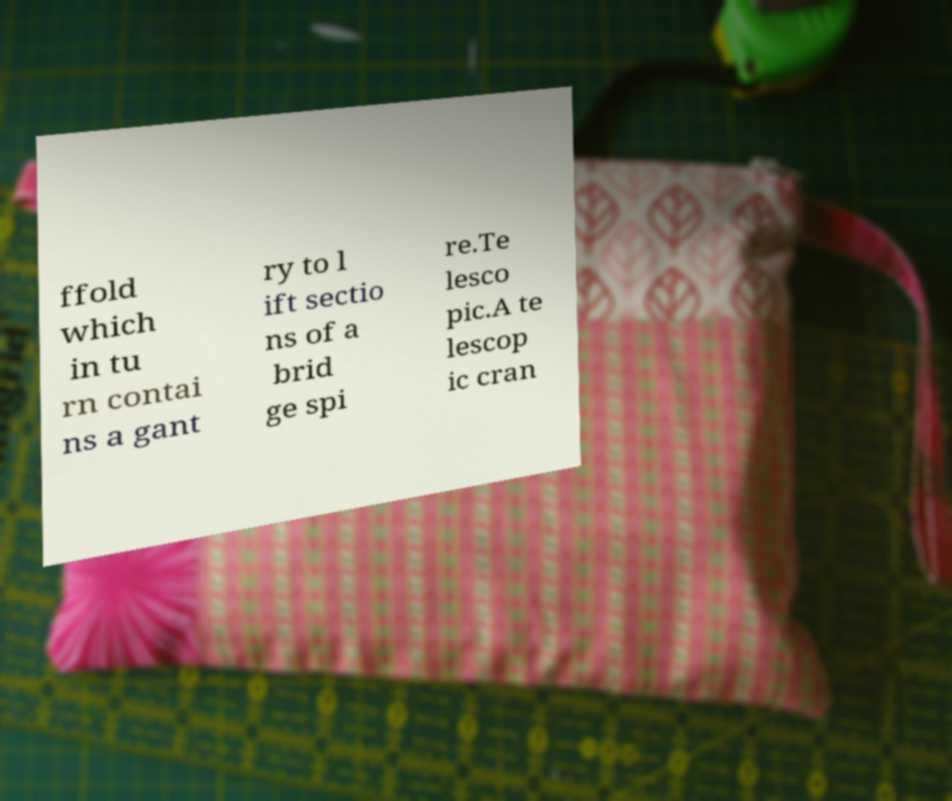For documentation purposes, I need the text within this image transcribed. Could you provide that? ffold which in tu rn contai ns a gant ry to l ift sectio ns of a brid ge spi re.Te lesco pic.A te lescop ic cran 